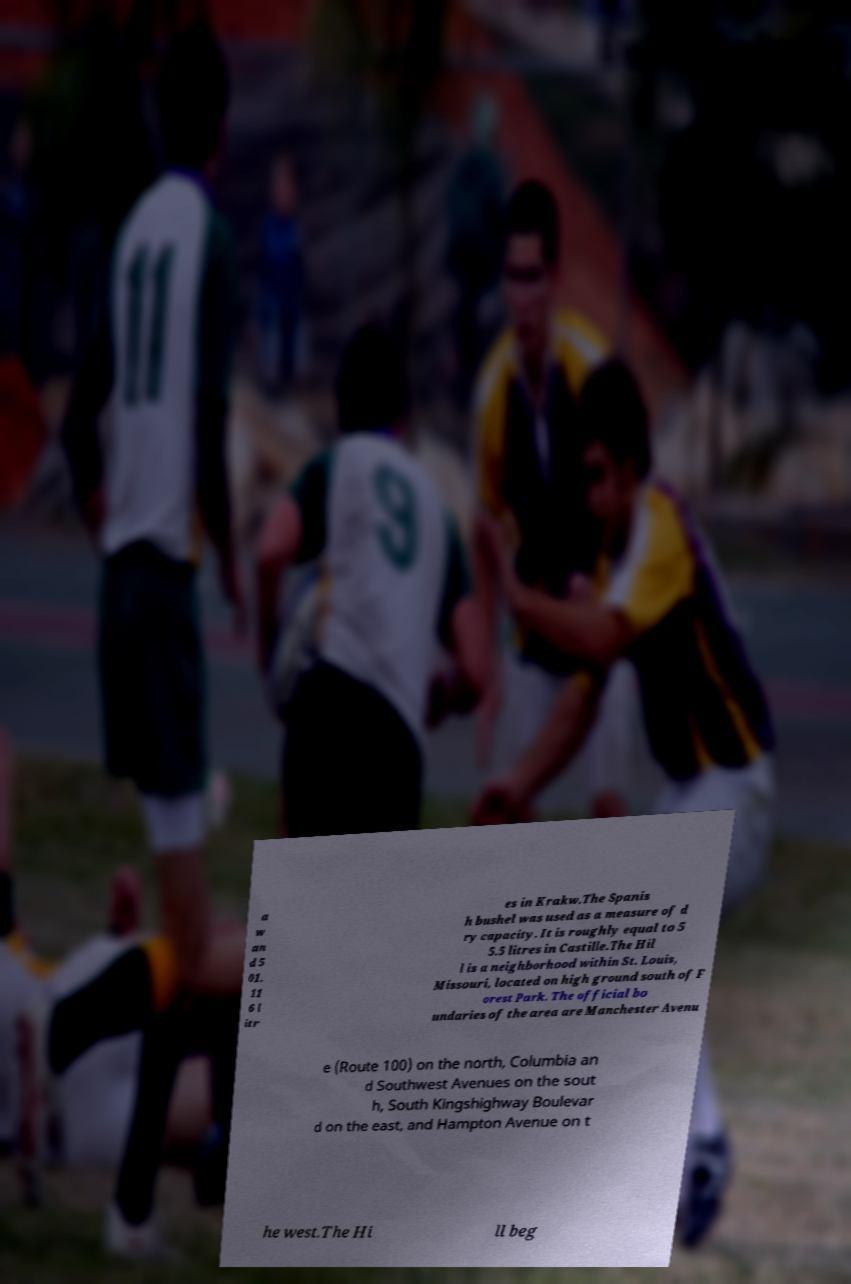Please read and relay the text visible in this image. What does it say? a w an d 5 01. 11 6 l itr es in Krakw.The Spanis h bushel was used as a measure of d ry capacity. It is roughly equal to 5 5.5 litres in Castille.The Hil l is a neighborhood within St. Louis, Missouri, located on high ground south of F orest Park. The official bo undaries of the area are Manchester Avenu e (Route 100) on the north, Columbia an d Southwest Avenues on the sout h, South Kingshighway Boulevar d on the east, and Hampton Avenue on t he west.The Hi ll beg 